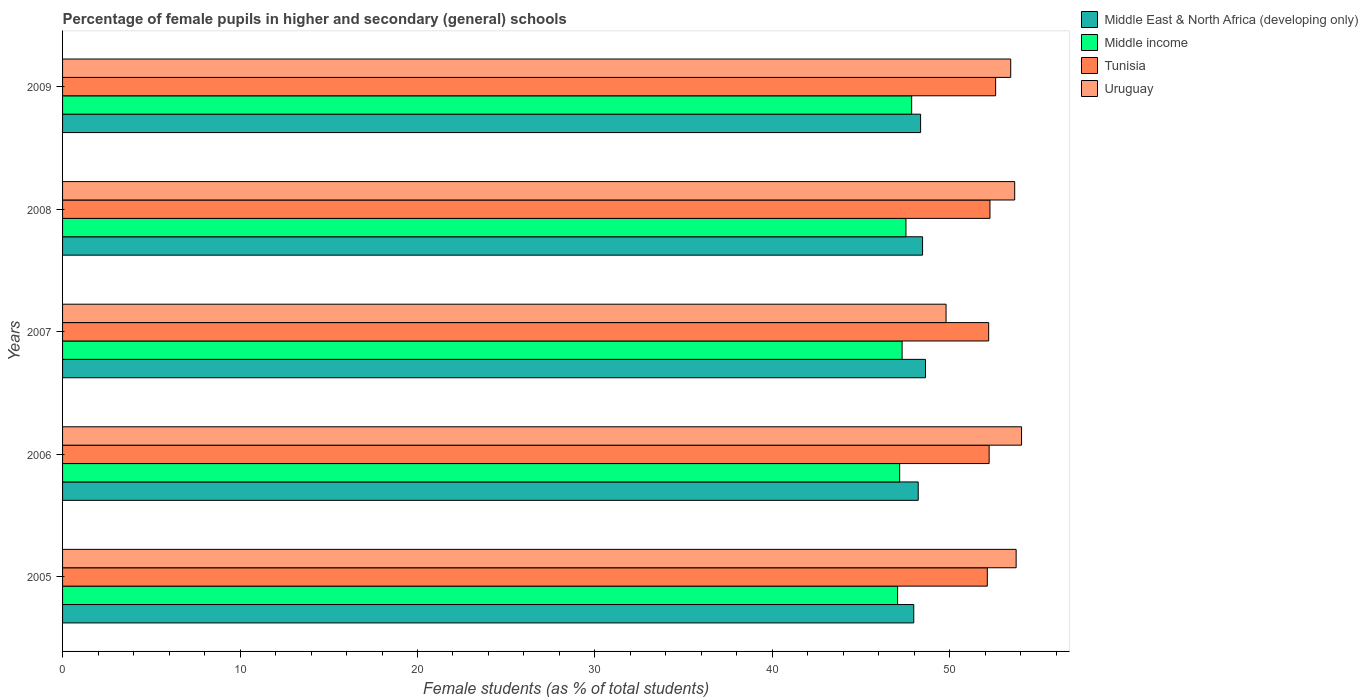How many groups of bars are there?
Offer a very short reply. 5. How many bars are there on the 3rd tick from the top?
Keep it short and to the point. 4. How many bars are there on the 5th tick from the bottom?
Make the answer very short. 4. What is the percentage of female pupils in higher and secondary schools in Tunisia in 2005?
Your answer should be compact. 52.11. Across all years, what is the maximum percentage of female pupils in higher and secondary schools in Middle East & North Africa (developing only)?
Provide a succinct answer. 48.62. Across all years, what is the minimum percentage of female pupils in higher and secondary schools in Middle East & North Africa (developing only)?
Make the answer very short. 47.96. In which year was the percentage of female pupils in higher and secondary schools in Middle income minimum?
Make the answer very short. 2005. What is the total percentage of female pupils in higher and secondary schools in Middle income in the graph?
Offer a terse response. 236.9. What is the difference between the percentage of female pupils in higher and secondary schools in Tunisia in 2008 and that in 2009?
Ensure brevity in your answer.  -0.32. What is the difference between the percentage of female pupils in higher and secondary schools in Middle income in 2005 and the percentage of female pupils in higher and secondary schools in Middle East & North Africa (developing only) in 2007?
Offer a terse response. -1.57. What is the average percentage of female pupils in higher and secondary schools in Middle income per year?
Offer a terse response. 47.38. In the year 2007, what is the difference between the percentage of female pupils in higher and secondary schools in Middle East & North Africa (developing only) and percentage of female pupils in higher and secondary schools in Uruguay?
Offer a terse response. -1.16. What is the ratio of the percentage of female pupils in higher and secondary schools in Uruguay in 2008 to that in 2009?
Keep it short and to the point. 1. Is the difference between the percentage of female pupils in higher and secondary schools in Middle East & North Africa (developing only) in 2006 and 2009 greater than the difference between the percentage of female pupils in higher and secondary schools in Uruguay in 2006 and 2009?
Your answer should be compact. No. What is the difference between the highest and the second highest percentage of female pupils in higher and secondary schools in Middle income?
Your answer should be very brief. 0.32. What is the difference between the highest and the lowest percentage of female pupils in higher and secondary schools in Middle East & North Africa (developing only)?
Keep it short and to the point. 0.66. In how many years, is the percentage of female pupils in higher and secondary schools in Middle income greater than the average percentage of female pupils in higher and secondary schools in Middle income taken over all years?
Your response must be concise. 2. Is the sum of the percentage of female pupils in higher and secondary schools in Tunisia in 2007 and 2008 greater than the maximum percentage of female pupils in higher and secondary schools in Middle income across all years?
Give a very brief answer. Yes. Is it the case that in every year, the sum of the percentage of female pupils in higher and secondary schools in Uruguay and percentage of female pupils in higher and secondary schools in Middle East & North Africa (developing only) is greater than the sum of percentage of female pupils in higher and secondary schools in Tunisia and percentage of female pupils in higher and secondary schools in Middle income?
Ensure brevity in your answer.  No. What does the 2nd bar from the top in 2007 represents?
Your answer should be very brief. Tunisia. What does the 3rd bar from the bottom in 2006 represents?
Your response must be concise. Tunisia. Is it the case that in every year, the sum of the percentage of female pupils in higher and secondary schools in Middle East & North Africa (developing only) and percentage of female pupils in higher and secondary schools in Uruguay is greater than the percentage of female pupils in higher and secondary schools in Middle income?
Provide a short and direct response. Yes. How many years are there in the graph?
Offer a very short reply. 5. Does the graph contain grids?
Your answer should be very brief. No. Where does the legend appear in the graph?
Offer a terse response. Top right. What is the title of the graph?
Make the answer very short. Percentage of female pupils in higher and secondary (general) schools. What is the label or title of the X-axis?
Your answer should be compact. Female students (as % of total students). What is the label or title of the Y-axis?
Your answer should be compact. Years. What is the Female students (as % of total students) of Middle East & North Africa (developing only) in 2005?
Offer a very short reply. 47.96. What is the Female students (as % of total students) of Middle income in 2005?
Make the answer very short. 47.05. What is the Female students (as % of total students) of Tunisia in 2005?
Ensure brevity in your answer.  52.11. What is the Female students (as % of total students) of Uruguay in 2005?
Your answer should be compact. 53.73. What is the Female students (as % of total students) of Middle East & North Africa (developing only) in 2006?
Offer a terse response. 48.22. What is the Female students (as % of total students) in Middle income in 2006?
Your response must be concise. 47.17. What is the Female students (as % of total students) in Tunisia in 2006?
Make the answer very short. 52.21. What is the Female students (as % of total students) of Uruguay in 2006?
Your answer should be very brief. 54.04. What is the Female students (as % of total students) of Middle East & North Africa (developing only) in 2007?
Offer a terse response. 48.62. What is the Female students (as % of total students) in Middle income in 2007?
Your answer should be very brief. 47.31. What is the Female students (as % of total students) of Tunisia in 2007?
Make the answer very short. 52.19. What is the Female students (as % of total students) in Uruguay in 2007?
Provide a succinct answer. 49.78. What is the Female students (as % of total students) of Middle East & North Africa (developing only) in 2008?
Your response must be concise. 48.46. What is the Female students (as % of total students) in Middle income in 2008?
Provide a short and direct response. 47.52. What is the Female students (as % of total students) of Tunisia in 2008?
Your answer should be very brief. 52.26. What is the Female students (as % of total students) in Uruguay in 2008?
Your answer should be compact. 53.65. What is the Female students (as % of total students) of Middle East & North Africa (developing only) in 2009?
Make the answer very short. 48.35. What is the Female students (as % of total students) of Middle income in 2009?
Provide a succinct answer. 47.85. What is the Female students (as % of total students) of Tunisia in 2009?
Keep it short and to the point. 52.58. What is the Female students (as % of total students) of Uruguay in 2009?
Make the answer very short. 53.43. Across all years, what is the maximum Female students (as % of total students) of Middle East & North Africa (developing only)?
Your response must be concise. 48.62. Across all years, what is the maximum Female students (as % of total students) of Middle income?
Offer a very short reply. 47.85. Across all years, what is the maximum Female students (as % of total students) in Tunisia?
Offer a terse response. 52.58. Across all years, what is the maximum Female students (as % of total students) of Uruguay?
Offer a terse response. 54.04. Across all years, what is the minimum Female students (as % of total students) in Middle East & North Africa (developing only)?
Provide a short and direct response. 47.96. Across all years, what is the minimum Female students (as % of total students) in Middle income?
Your answer should be compact. 47.05. Across all years, what is the minimum Female students (as % of total students) of Tunisia?
Ensure brevity in your answer.  52.11. Across all years, what is the minimum Female students (as % of total students) of Uruguay?
Make the answer very short. 49.78. What is the total Female students (as % of total students) of Middle East & North Africa (developing only) in the graph?
Give a very brief answer. 241.61. What is the total Female students (as % of total students) in Middle income in the graph?
Make the answer very short. 236.9. What is the total Female students (as % of total students) in Tunisia in the graph?
Provide a short and direct response. 261.34. What is the total Female students (as % of total students) in Uruguay in the graph?
Keep it short and to the point. 264.64. What is the difference between the Female students (as % of total students) of Middle East & North Africa (developing only) in 2005 and that in 2006?
Keep it short and to the point. -0.25. What is the difference between the Female students (as % of total students) of Middle income in 2005 and that in 2006?
Ensure brevity in your answer.  -0.12. What is the difference between the Female students (as % of total students) in Tunisia in 2005 and that in 2006?
Ensure brevity in your answer.  -0.1. What is the difference between the Female students (as % of total students) in Uruguay in 2005 and that in 2006?
Your response must be concise. -0.3. What is the difference between the Female students (as % of total students) of Middle East & North Africa (developing only) in 2005 and that in 2007?
Keep it short and to the point. -0.66. What is the difference between the Female students (as % of total students) of Middle income in 2005 and that in 2007?
Your answer should be compact. -0.25. What is the difference between the Female students (as % of total students) of Tunisia in 2005 and that in 2007?
Provide a succinct answer. -0.08. What is the difference between the Female students (as % of total students) in Uruguay in 2005 and that in 2007?
Ensure brevity in your answer.  3.95. What is the difference between the Female students (as % of total students) in Middle East & North Africa (developing only) in 2005 and that in 2008?
Your answer should be compact. -0.5. What is the difference between the Female students (as % of total students) in Middle income in 2005 and that in 2008?
Make the answer very short. -0.47. What is the difference between the Female students (as % of total students) of Tunisia in 2005 and that in 2008?
Make the answer very short. -0.15. What is the difference between the Female students (as % of total students) in Uruguay in 2005 and that in 2008?
Offer a terse response. 0.08. What is the difference between the Female students (as % of total students) in Middle East & North Africa (developing only) in 2005 and that in 2009?
Ensure brevity in your answer.  -0.38. What is the difference between the Female students (as % of total students) of Middle income in 2005 and that in 2009?
Your response must be concise. -0.79. What is the difference between the Female students (as % of total students) in Tunisia in 2005 and that in 2009?
Your response must be concise. -0.47. What is the difference between the Female students (as % of total students) of Uruguay in 2005 and that in 2009?
Keep it short and to the point. 0.31. What is the difference between the Female students (as % of total students) in Middle East & North Africa (developing only) in 2006 and that in 2007?
Offer a terse response. -0.41. What is the difference between the Female students (as % of total students) of Middle income in 2006 and that in 2007?
Provide a succinct answer. -0.14. What is the difference between the Female students (as % of total students) of Tunisia in 2006 and that in 2007?
Your answer should be compact. 0.03. What is the difference between the Female students (as % of total students) in Uruguay in 2006 and that in 2007?
Offer a very short reply. 4.25. What is the difference between the Female students (as % of total students) of Middle East & North Africa (developing only) in 2006 and that in 2008?
Make the answer very short. -0.24. What is the difference between the Female students (as % of total students) in Middle income in 2006 and that in 2008?
Keep it short and to the point. -0.35. What is the difference between the Female students (as % of total students) in Tunisia in 2006 and that in 2008?
Offer a terse response. -0.05. What is the difference between the Female students (as % of total students) in Uruguay in 2006 and that in 2008?
Your response must be concise. 0.39. What is the difference between the Female students (as % of total students) in Middle East & North Africa (developing only) in 2006 and that in 2009?
Offer a very short reply. -0.13. What is the difference between the Female students (as % of total students) of Middle income in 2006 and that in 2009?
Offer a very short reply. -0.68. What is the difference between the Female students (as % of total students) in Tunisia in 2006 and that in 2009?
Your answer should be compact. -0.37. What is the difference between the Female students (as % of total students) of Uruguay in 2006 and that in 2009?
Provide a succinct answer. 0.61. What is the difference between the Female students (as % of total students) of Middle East & North Africa (developing only) in 2007 and that in 2008?
Give a very brief answer. 0.16. What is the difference between the Female students (as % of total students) of Middle income in 2007 and that in 2008?
Offer a very short reply. -0.22. What is the difference between the Female students (as % of total students) of Tunisia in 2007 and that in 2008?
Provide a short and direct response. -0.07. What is the difference between the Female students (as % of total students) in Uruguay in 2007 and that in 2008?
Keep it short and to the point. -3.87. What is the difference between the Female students (as % of total students) of Middle East & North Africa (developing only) in 2007 and that in 2009?
Give a very brief answer. 0.28. What is the difference between the Female students (as % of total students) of Middle income in 2007 and that in 2009?
Provide a succinct answer. -0.54. What is the difference between the Female students (as % of total students) in Tunisia in 2007 and that in 2009?
Ensure brevity in your answer.  -0.39. What is the difference between the Female students (as % of total students) in Uruguay in 2007 and that in 2009?
Offer a terse response. -3.64. What is the difference between the Female students (as % of total students) of Middle East & North Africa (developing only) in 2008 and that in 2009?
Offer a very short reply. 0.11. What is the difference between the Female students (as % of total students) of Middle income in 2008 and that in 2009?
Make the answer very short. -0.32. What is the difference between the Female students (as % of total students) in Tunisia in 2008 and that in 2009?
Ensure brevity in your answer.  -0.32. What is the difference between the Female students (as % of total students) in Uruguay in 2008 and that in 2009?
Provide a succinct answer. 0.22. What is the difference between the Female students (as % of total students) of Middle East & North Africa (developing only) in 2005 and the Female students (as % of total students) of Middle income in 2006?
Your response must be concise. 0.79. What is the difference between the Female students (as % of total students) of Middle East & North Africa (developing only) in 2005 and the Female students (as % of total students) of Tunisia in 2006?
Your answer should be very brief. -4.25. What is the difference between the Female students (as % of total students) of Middle East & North Africa (developing only) in 2005 and the Female students (as % of total students) of Uruguay in 2006?
Your answer should be very brief. -6.07. What is the difference between the Female students (as % of total students) of Middle income in 2005 and the Female students (as % of total students) of Tunisia in 2006?
Keep it short and to the point. -5.16. What is the difference between the Female students (as % of total students) of Middle income in 2005 and the Female students (as % of total students) of Uruguay in 2006?
Ensure brevity in your answer.  -6.98. What is the difference between the Female students (as % of total students) of Tunisia in 2005 and the Female students (as % of total students) of Uruguay in 2006?
Your answer should be compact. -1.93. What is the difference between the Female students (as % of total students) of Middle East & North Africa (developing only) in 2005 and the Female students (as % of total students) of Middle income in 2007?
Your answer should be very brief. 0.66. What is the difference between the Female students (as % of total students) in Middle East & North Africa (developing only) in 2005 and the Female students (as % of total students) in Tunisia in 2007?
Offer a very short reply. -4.22. What is the difference between the Female students (as % of total students) in Middle East & North Africa (developing only) in 2005 and the Female students (as % of total students) in Uruguay in 2007?
Your answer should be very brief. -1.82. What is the difference between the Female students (as % of total students) of Middle income in 2005 and the Female students (as % of total students) of Tunisia in 2007?
Keep it short and to the point. -5.13. What is the difference between the Female students (as % of total students) in Middle income in 2005 and the Female students (as % of total students) in Uruguay in 2007?
Give a very brief answer. -2.73. What is the difference between the Female students (as % of total students) in Tunisia in 2005 and the Female students (as % of total students) in Uruguay in 2007?
Give a very brief answer. 2.33. What is the difference between the Female students (as % of total students) of Middle East & North Africa (developing only) in 2005 and the Female students (as % of total students) of Middle income in 2008?
Your response must be concise. 0.44. What is the difference between the Female students (as % of total students) in Middle East & North Africa (developing only) in 2005 and the Female students (as % of total students) in Tunisia in 2008?
Offer a terse response. -4.29. What is the difference between the Female students (as % of total students) of Middle East & North Africa (developing only) in 2005 and the Female students (as % of total students) of Uruguay in 2008?
Your answer should be compact. -5.69. What is the difference between the Female students (as % of total students) in Middle income in 2005 and the Female students (as % of total students) in Tunisia in 2008?
Provide a short and direct response. -5.2. What is the difference between the Female students (as % of total students) in Middle income in 2005 and the Female students (as % of total students) in Uruguay in 2008?
Offer a very short reply. -6.6. What is the difference between the Female students (as % of total students) in Tunisia in 2005 and the Female students (as % of total students) in Uruguay in 2008?
Your answer should be compact. -1.54. What is the difference between the Female students (as % of total students) of Middle East & North Africa (developing only) in 2005 and the Female students (as % of total students) of Middle income in 2009?
Your answer should be compact. 0.12. What is the difference between the Female students (as % of total students) in Middle East & North Africa (developing only) in 2005 and the Female students (as % of total students) in Tunisia in 2009?
Offer a terse response. -4.61. What is the difference between the Female students (as % of total students) of Middle East & North Africa (developing only) in 2005 and the Female students (as % of total students) of Uruguay in 2009?
Your answer should be compact. -5.46. What is the difference between the Female students (as % of total students) in Middle income in 2005 and the Female students (as % of total students) in Tunisia in 2009?
Offer a terse response. -5.52. What is the difference between the Female students (as % of total students) of Middle income in 2005 and the Female students (as % of total students) of Uruguay in 2009?
Make the answer very short. -6.37. What is the difference between the Female students (as % of total students) in Tunisia in 2005 and the Female students (as % of total students) in Uruguay in 2009?
Give a very brief answer. -1.32. What is the difference between the Female students (as % of total students) of Middle East & North Africa (developing only) in 2006 and the Female students (as % of total students) of Middle income in 2007?
Offer a terse response. 0.91. What is the difference between the Female students (as % of total students) in Middle East & North Africa (developing only) in 2006 and the Female students (as % of total students) in Tunisia in 2007?
Make the answer very short. -3.97. What is the difference between the Female students (as % of total students) in Middle East & North Africa (developing only) in 2006 and the Female students (as % of total students) in Uruguay in 2007?
Provide a succinct answer. -1.57. What is the difference between the Female students (as % of total students) of Middle income in 2006 and the Female students (as % of total students) of Tunisia in 2007?
Offer a very short reply. -5.02. What is the difference between the Female students (as % of total students) of Middle income in 2006 and the Female students (as % of total students) of Uruguay in 2007?
Provide a short and direct response. -2.61. What is the difference between the Female students (as % of total students) of Tunisia in 2006 and the Female students (as % of total students) of Uruguay in 2007?
Ensure brevity in your answer.  2.43. What is the difference between the Female students (as % of total students) of Middle East & North Africa (developing only) in 2006 and the Female students (as % of total students) of Middle income in 2008?
Keep it short and to the point. 0.69. What is the difference between the Female students (as % of total students) in Middle East & North Africa (developing only) in 2006 and the Female students (as % of total students) in Tunisia in 2008?
Provide a short and direct response. -4.04. What is the difference between the Female students (as % of total students) of Middle East & North Africa (developing only) in 2006 and the Female students (as % of total students) of Uruguay in 2008?
Your answer should be compact. -5.44. What is the difference between the Female students (as % of total students) in Middle income in 2006 and the Female students (as % of total students) in Tunisia in 2008?
Your answer should be compact. -5.09. What is the difference between the Female students (as % of total students) of Middle income in 2006 and the Female students (as % of total students) of Uruguay in 2008?
Keep it short and to the point. -6.48. What is the difference between the Female students (as % of total students) of Tunisia in 2006 and the Female students (as % of total students) of Uruguay in 2008?
Your answer should be very brief. -1.44. What is the difference between the Female students (as % of total students) of Middle East & North Africa (developing only) in 2006 and the Female students (as % of total students) of Middle income in 2009?
Provide a short and direct response. 0.37. What is the difference between the Female students (as % of total students) of Middle East & North Africa (developing only) in 2006 and the Female students (as % of total students) of Tunisia in 2009?
Offer a terse response. -4.36. What is the difference between the Female students (as % of total students) of Middle East & North Africa (developing only) in 2006 and the Female students (as % of total students) of Uruguay in 2009?
Offer a very short reply. -5.21. What is the difference between the Female students (as % of total students) in Middle income in 2006 and the Female students (as % of total students) in Tunisia in 2009?
Make the answer very short. -5.41. What is the difference between the Female students (as % of total students) of Middle income in 2006 and the Female students (as % of total students) of Uruguay in 2009?
Offer a terse response. -6.26. What is the difference between the Female students (as % of total students) in Tunisia in 2006 and the Female students (as % of total students) in Uruguay in 2009?
Ensure brevity in your answer.  -1.22. What is the difference between the Female students (as % of total students) of Middle East & North Africa (developing only) in 2007 and the Female students (as % of total students) of Middle income in 2008?
Your response must be concise. 1.1. What is the difference between the Female students (as % of total students) in Middle East & North Africa (developing only) in 2007 and the Female students (as % of total students) in Tunisia in 2008?
Your answer should be very brief. -3.63. What is the difference between the Female students (as % of total students) of Middle East & North Africa (developing only) in 2007 and the Female students (as % of total students) of Uruguay in 2008?
Give a very brief answer. -5.03. What is the difference between the Female students (as % of total students) in Middle income in 2007 and the Female students (as % of total students) in Tunisia in 2008?
Provide a short and direct response. -4.95. What is the difference between the Female students (as % of total students) in Middle income in 2007 and the Female students (as % of total students) in Uruguay in 2008?
Offer a very short reply. -6.34. What is the difference between the Female students (as % of total students) in Tunisia in 2007 and the Female students (as % of total students) in Uruguay in 2008?
Make the answer very short. -1.47. What is the difference between the Female students (as % of total students) of Middle East & North Africa (developing only) in 2007 and the Female students (as % of total students) of Middle income in 2009?
Give a very brief answer. 0.78. What is the difference between the Female students (as % of total students) in Middle East & North Africa (developing only) in 2007 and the Female students (as % of total students) in Tunisia in 2009?
Give a very brief answer. -3.95. What is the difference between the Female students (as % of total students) of Middle East & North Africa (developing only) in 2007 and the Female students (as % of total students) of Uruguay in 2009?
Offer a very short reply. -4.8. What is the difference between the Female students (as % of total students) of Middle income in 2007 and the Female students (as % of total students) of Tunisia in 2009?
Offer a terse response. -5.27. What is the difference between the Female students (as % of total students) of Middle income in 2007 and the Female students (as % of total students) of Uruguay in 2009?
Provide a short and direct response. -6.12. What is the difference between the Female students (as % of total students) in Tunisia in 2007 and the Female students (as % of total students) in Uruguay in 2009?
Your response must be concise. -1.24. What is the difference between the Female students (as % of total students) of Middle East & North Africa (developing only) in 2008 and the Female students (as % of total students) of Middle income in 2009?
Offer a terse response. 0.61. What is the difference between the Female students (as % of total students) of Middle East & North Africa (developing only) in 2008 and the Female students (as % of total students) of Tunisia in 2009?
Provide a succinct answer. -4.12. What is the difference between the Female students (as % of total students) of Middle East & North Africa (developing only) in 2008 and the Female students (as % of total students) of Uruguay in 2009?
Your answer should be compact. -4.97. What is the difference between the Female students (as % of total students) in Middle income in 2008 and the Female students (as % of total students) in Tunisia in 2009?
Your answer should be compact. -5.05. What is the difference between the Female students (as % of total students) in Middle income in 2008 and the Female students (as % of total students) in Uruguay in 2009?
Provide a succinct answer. -5.9. What is the difference between the Female students (as % of total students) of Tunisia in 2008 and the Female students (as % of total students) of Uruguay in 2009?
Your answer should be very brief. -1.17. What is the average Female students (as % of total students) of Middle East & North Africa (developing only) per year?
Provide a short and direct response. 48.32. What is the average Female students (as % of total students) in Middle income per year?
Keep it short and to the point. 47.38. What is the average Female students (as % of total students) in Tunisia per year?
Your response must be concise. 52.27. What is the average Female students (as % of total students) in Uruguay per year?
Your response must be concise. 52.93. In the year 2005, what is the difference between the Female students (as % of total students) of Middle East & North Africa (developing only) and Female students (as % of total students) of Middle income?
Keep it short and to the point. 0.91. In the year 2005, what is the difference between the Female students (as % of total students) of Middle East & North Africa (developing only) and Female students (as % of total students) of Tunisia?
Your answer should be very brief. -4.15. In the year 2005, what is the difference between the Female students (as % of total students) in Middle East & North Africa (developing only) and Female students (as % of total students) in Uruguay?
Provide a succinct answer. -5.77. In the year 2005, what is the difference between the Female students (as % of total students) in Middle income and Female students (as % of total students) in Tunisia?
Provide a short and direct response. -5.06. In the year 2005, what is the difference between the Female students (as % of total students) of Middle income and Female students (as % of total students) of Uruguay?
Provide a succinct answer. -6.68. In the year 2005, what is the difference between the Female students (as % of total students) of Tunisia and Female students (as % of total students) of Uruguay?
Offer a very short reply. -1.62. In the year 2006, what is the difference between the Female students (as % of total students) in Middle East & North Africa (developing only) and Female students (as % of total students) in Middle income?
Make the answer very short. 1.05. In the year 2006, what is the difference between the Female students (as % of total students) in Middle East & North Africa (developing only) and Female students (as % of total students) in Tunisia?
Offer a very short reply. -4. In the year 2006, what is the difference between the Female students (as % of total students) of Middle East & North Africa (developing only) and Female students (as % of total students) of Uruguay?
Give a very brief answer. -5.82. In the year 2006, what is the difference between the Female students (as % of total students) of Middle income and Female students (as % of total students) of Tunisia?
Offer a terse response. -5.04. In the year 2006, what is the difference between the Female students (as % of total students) in Middle income and Female students (as % of total students) in Uruguay?
Ensure brevity in your answer.  -6.87. In the year 2006, what is the difference between the Female students (as % of total students) in Tunisia and Female students (as % of total students) in Uruguay?
Keep it short and to the point. -1.83. In the year 2007, what is the difference between the Female students (as % of total students) of Middle East & North Africa (developing only) and Female students (as % of total students) of Middle income?
Provide a succinct answer. 1.32. In the year 2007, what is the difference between the Female students (as % of total students) of Middle East & North Africa (developing only) and Female students (as % of total students) of Tunisia?
Your answer should be very brief. -3.56. In the year 2007, what is the difference between the Female students (as % of total students) of Middle East & North Africa (developing only) and Female students (as % of total students) of Uruguay?
Your answer should be compact. -1.16. In the year 2007, what is the difference between the Female students (as % of total students) of Middle income and Female students (as % of total students) of Tunisia?
Offer a terse response. -4.88. In the year 2007, what is the difference between the Female students (as % of total students) in Middle income and Female students (as % of total students) in Uruguay?
Ensure brevity in your answer.  -2.48. In the year 2007, what is the difference between the Female students (as % of total students) of Tunisia and Female students (as % of total students) of Uruguay?
Ensure brevity in your answer.  2.4. In the year 2008, what is the difference between the Female students (as % of total students) of Middle East & North Africa (developing only) and Female students (as % of total students) of Middle income?
Your answer should be very brief. 0.94. In the year 2008, what is the difference between the Female students (as % of total students) in Middle East & North Africa (developing only) and Female students (as % of total students) in Tunisia?
Your response must be concise. -3.8. In the year 2008, what is the difference between the Female students (as % of total students) in Middle East & North Africa (developing only) and Female students (as % of total students) in Uruguay?
Your answer should be compact. -5.19. In the year 2008, what is the difference between the Female students (as % of total students) in Middle income and Female students (as % of total students) in Tunisia?
Keep it short and to the point. -4.73. In the year 2008, what is the difference between the Female students (as % of total students) of Middle income and Female students (as % of total students) of Uruguay?
Your response must be concise. -6.13. In the year 2008, what is the difference between the Female students (as % of total students) in Tunisia and Female students (as % of total students) in Uruguay?
Keep it short and to the point. -1.39. In the year 2009, what is the difference between the Female students (as % of total students) in Middle East & North Africa (developing only) and Female students (as % of total students) in Middle income?
Provide a short and direct response. 0.5. In the year 2009, what is the difference between the Female students (as % of total students) of Middle East & North Africa (developing only) and Female students (as % of total students) of Tunisia?
Give a very brief answer. -4.23. In the year 2009, what is the difference between the Female students (as % of total students) in Middle East & North Africa (developing only) and Female students (as % of total students) in Uruguay?
Your answer should be very brief. -5.08. In the year 2009, what is the difference between the Female students (as % of total students) in Middle income and Female students (as % of total students) in Tunisia?
Ensure brevity in your answer.  -4.73. In the year 2009, what is the difference between the Female students (as % of total students) of Middle income and Female students (as % of total students) of Uruguay?
Make the answer very short. -5.58. In the year 2009, what is the difference between the Female students (as % of total students) in Tunisia and Female students (as % of total students) in Uruguay?
Give a very brief answer. -0.85. What is the ratio of the Female students (as % of total students) of Middle East & North Africa (developing only) in 2005 to that in 2006?
Offer a very short reply. 0.99. What is the ratio of the Female students (as % of total students) in Middle income in 2005 to that in 2006?
Your answer should be very brief. 1. What is the ratio of the Female students (as % of total students) in Tunisia in 2005 to that in 2006?
Ensure brevity in your answer.  1. What is the ratio of the Female students (as % of total students) of Uruguay in 2005 to that in 2006?
Your answer should be very brief. 0.99. What is the ratio of the Female students (as % of total students) of Middle East & North Africa (developing only) in 2005 to that in 2007?
Ensure brevity in your answer.  0.99. What is the ratio of the Female students (as % of total students) of Middle income in 2005 to that in 2007?
Provide a succinct answer. 0.99. What is the ratio of the Female students (as % of total students) of Uruguay in 2005 to that in 2007?
Provide a succinct answer. 1.08. What is the ratio of the Female students (as % of total students) in Middle East & North Africa (developing only) in 2005 to that in 2008?
Give a very brief answer. 0.99. What is the ratio of the Female students (as % of total students) of Uruguay in 2005 to that in 2008?
Keep it short and to the point. 1. What is the ratio of the Female students (as % of total students) of Middle East & North Africa (developing only) in 2005 to that in 2009?
Offer a terse response. 0.99. What is the ratio of the Female students (as % of total students) in Middle income in 2005 to that in 2009?
Ensure brevity in your answer.  0.98. What is the ratio of the Female students (as % of total students) of Tunisia in 2005 to that in 2009?
Your answer should be very brief. 0.99. What is the ratio of the Female students (as % of total students) in Uruguay in 2005 to that in 2009?
Your answer should be very brief. 1.01. What is the ratio of the Female students (as % of total students) in Middle East & North Africa (developing only) in 2006 to that in 2007?
Provide a succinct answer. 0.99. What is the ratio of the Female students (as % of total students) in Tunisia in 2006 to that in 2007?
Your answer should be very brief. 1. What is the ratio of the Female students (as % of total students) in Uruguay in 2006 to that in 2007?
Provide a succinct answer. 1.09. What is the ratio of the Female students (as % of total students) of Middle East & North Africa (developing only) in 2006 to that in 2008?
Your answer should be compact. 0.99. What is the ratio of the Female students (as % of total students) of Middle income in 2006 to that in 2008?
Offer a terse response. 0.99. What is the ratio of the Female students (as % of total students) in Tunisia in 2006 to that in 2008?
Offer a very short reply. 1. What is the ratio of the Female students (as % of total students) in Middle East & North Africa (developing only) in 2006 to that in 2009?
Your response must be concise. 1. What is the ratio of the Female students (as % of total students) in Middle income in 2006 to that in 2009?
Offer a very short reply. 0.99. What is the ratio of the Female students (as % of total students) of Tunisia in 2006 to that in 2009?
Make the answer very short. 0.99. What is the ratio of the Female students (as % of total students) of Uruguay in 2006 to that in 2009?
Your response must be concise. 1.01. What is the ratio of the Female students (as % of total students) in Middle income in 2007 to that in 2008?
Provide a succinct answer. 1. What is the ratio of the Female students (as % of total students) of Tunisia in 2007 to that in 2008?
Offer a very short reply. 1. What is the ratio of the Female students (as % of total students) of Uruguay in 2007 to that in 2008?
Your response must be concise. 0.93. What is the ratio of the Female students (as % of total students) in Middle East & North Africa (developing only) in 2007 to that in 2009?
Offer a terse response. 1.01. What is the ratio of the Female students (as % of total students) of Middle income in 2007 to that in 2009?
Make the answer very short. 0.99. What is the ratio of the Female students (as % of total students) in Tunisia in 2007 to that in 2009?
Your answer should be compact. 0.99. What is the ratio of the Female students (as % of total students) in Uruguay in 2007 to that in 2009?
Provide a succinct answer. 0.93. What is the ratio of the Female students (as % of total students) of Middle income in 2008 to that in 2009?
Your answer should be compact. 0.99. What is the ratio of the Female students (as % of total students) of Tunisia in 2008 to that in 2009?
Your answer should be very brief. 0.99. What is the difference between the highest and the second highest Female students (as % of total students) in Middle East & North Africa (developing only)?
Keep it short and to the point. 0.16. What is the difference between the highest and the second highest Female students (as % of total students) of Middle income?
Provide a short and direct response. 0.32. What is the difference between the highest and the second highest Female students (as % of total students) in Tunisia?
Your answer should be very brief. 0.32. What is the difference between the highest and the second highest Female students (as % of total students) in Uruguay?
Provide a succinct answer. 0.3. What is the difference between the highest and the lowest Female students (as % of total students) in Middle East & North Africa (developing only)?
Your response must be concise. 0.66. What is the difference between the highest and the lowest Female students (as % of total students) of Middle income?
Offer a terse response. 0.79. What is the difference between the highest and the lowest Female students (as % of total students) of Tunisia?
Provide a short and direct response. 0.47. What is the difference between the highest and the lowest Female students (as % of total students) in Uruguay?
Your response must be concise. 4.25. 